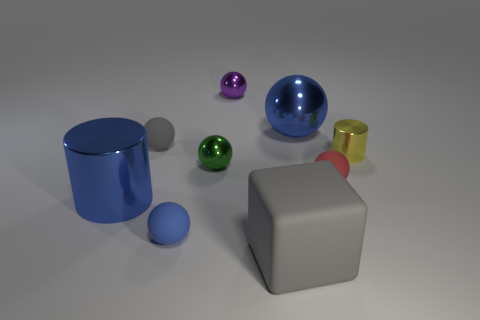What is the color of the metallic cylinder that is the same size as the red thing?
Offer a terse response. Yellow. How many large blue objects are in front of the small green metal ball?
Offer a terse response. 1. Are there any brown spheres?
Ensure brevity in your answer.  No. There is a metallic cylinder on the left side of the large thing that is behind the cylinder that is in front of the small red rubber sphere; how big is it?
Your response must be concise. Large. What number of other objects are there of the same size as the green thing?
Provide a succinct answer. 5. There is a metallic ball that is in front of the gray matte sphere; what is its size?
Offer a very short reply. Small. Is there any other thing that is the same color as the big cylinder?
Your answer should be very brief. Yes. Do the blue sphere on the right side of the tiny blue sphere and the tiny red sphere have the same material?
Provide a succinct answer. No. What number of objects are both left of the small red matte object and behind the large blue metallic cylinder?
Ensure brevity in your answer.  4. There is a metallic cylinder in front of the small yellow shiny cylinder on the right side of the tiny red rubber sphere; how big is it?
Make the answer very short. Large. 